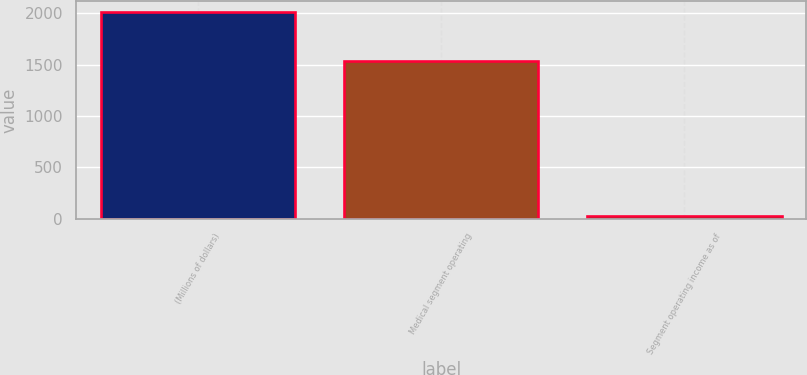<chart> <loc_0><loc_0><loc_500><loc_500><bar_chart><fcel>(Millions of dollars)<fcel>Medical segment operating<fcel>Segment operating income as of<nl><fcel>2015<fcel>1530<fcel>23.7<nl></chart> 